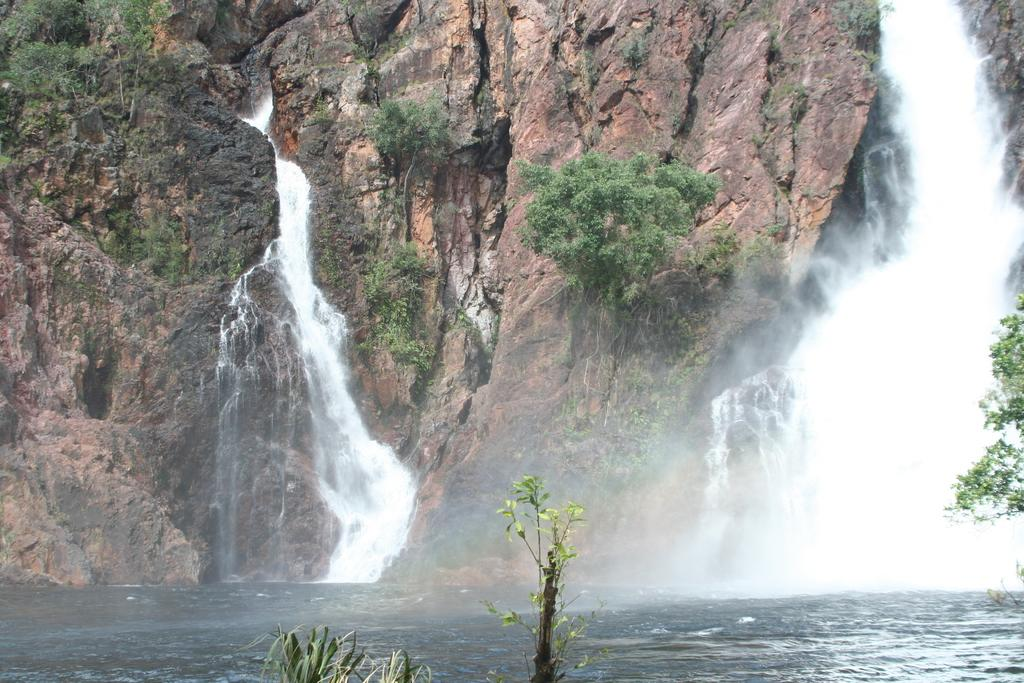What natural feature is present in the image? There is a waterfall in the image. What type of vegetation can be seen in the image? There are trees in the image. What geological features are visible in the image? There are big rocks in the image. What type of committee is meeting near the waterfall in the image? There is no committee meeting near the waterfall in the image; it is a natural scene with no human-made structures or gatherings. Can you tell me how many potatoes are visible in the image? There are no potatoes present in the image; it features a waterfall, trees, and big rocks. 